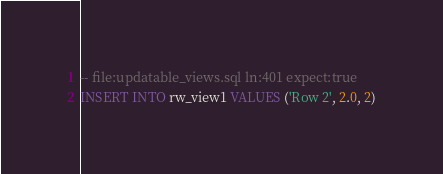<code> <loc_0><loc_0><loc_500><loc_500><_SQL_>-- file:updatable_views.sql ln:401 expect:true
INSERT INTO rw_view1 VALUES ('Row 2', 2.0, 2)
</code> 